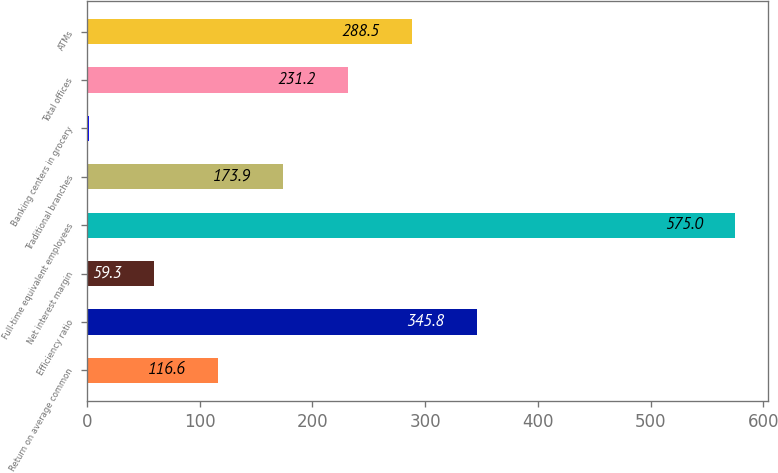Convert chart. <chart><loc_0><loc_0><loc_500><loc_500><bar_chart><fcel>Return on average common<fcel>Efficiency ratio<fcel>Net interest margin<fcel>Full-time equivalent employees<fcel>Traditional branches<fcel>Banking centers in grocery<fcel>Total offices<fcel>ATMs<nl><fcel>116.6<fcel>345.8<fcel>59.3<fcel>575<fcel>173.9<fcel>2<fcel>231.2<fcel>288.5<nl></chart> 